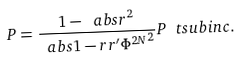Convert formula to latex. <formula><loc_0><loc_0><loc_500><loc_500>P = \frac { 1 - \ a b s { r } ^ { 2 } } { \ a b s { 1 - r r ^ { \prime } \Phi ^ { 2 N } } ^ { 2 } } P \ t s u b { i n c } .</formula> 